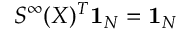<formula> <loc_0><loc_0><loc_500><loc_500>S ^ { \infty } ( X ) ^ { T } 1 _ { N } = 1 _ { N }</formula> 